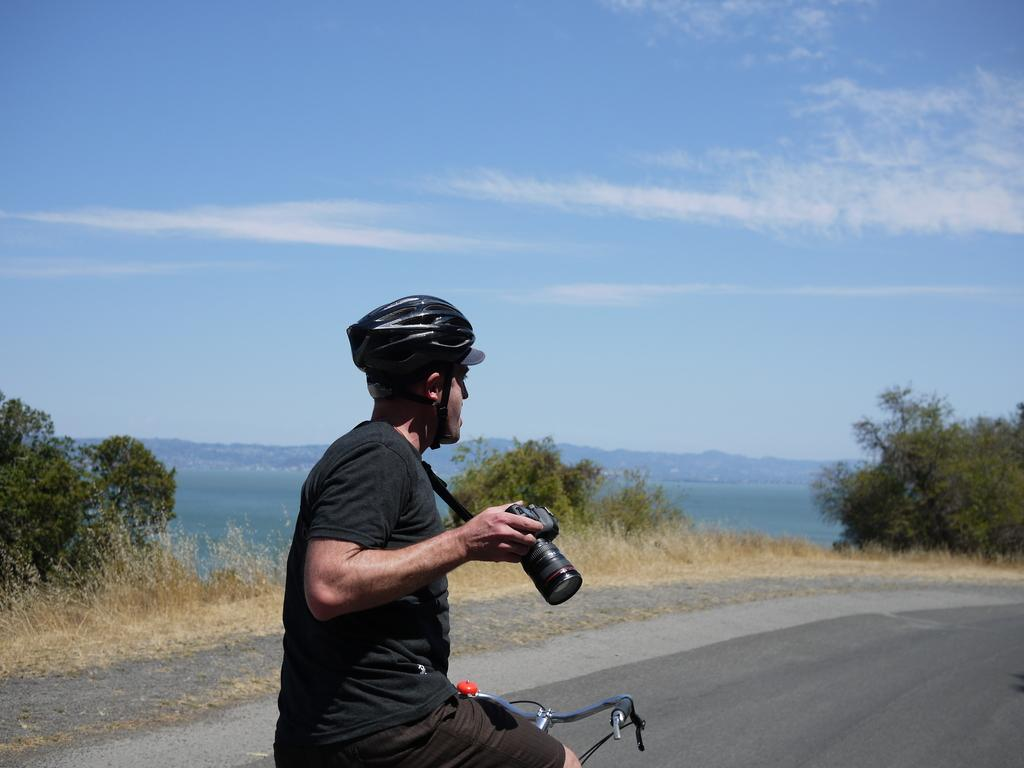What is the person in the image doing? The person is riding a bicycle in the image. What is the person holding while riding the bicycle? The person is holding a camera in their hand. What can be seen in the background of the image? There is a sky, trees, and a road visible in the background of the image. What is the condition of the sky in the image? The sky has clouds in it. What type of silver object is the person using to take a picture in the image? There is no silver object present in the image; the person is holding a camera, but its material is not mentioned. How many fingers is the person using to hold the camera in the image? The number of fingers the person is using to hold the camera cannot be determined from the image. 